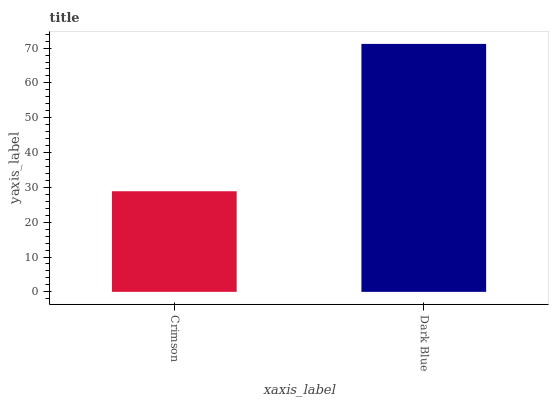Is Crimson the minimum?
Answer yes or no. Yes. Is Dark Blue the maximum?
Answer yes or no. Yes. Is Dark Blue the minimum?
Answer yes or no. No. Is Dark Blue greater than Crimson?
Answer yes or no. Yes. Is Crimson less than Dark Blue?
Answer yes or no. Yes. Is Crimson greater than Dark Blue?
Answer yes or no. No. Is Dark Blue less than Crimson?
Answer yes or no. No. Is Dark Blue the high median?
Answer yes or no. Yes. Is Crimson the low median?
Answer yes or no. Yes. Is Crimson the high median?
Answer yes or no. No. Is Dark Blue the low median?
Answer yes or no. No. 